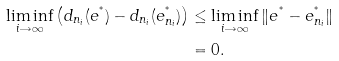Convert formula to latex. <formula><loc_0><loc_0><loc_500><loc_500>\liminf _ { i \rightarrow \infty } \left ( d _ { n _ { i } } ( e ^ { ^ { * } } ) - d _ { n _ { i } } ( e _ { n _ { i } } ^ { ^ { * } } ) \right ) & \leq \liminf _ { i \rightarrow \infty } \| e ^ { ^ { * } } - e _ { n _ { i } } ^ { ^ { * } } \| \\ & = 0 .</formula> 